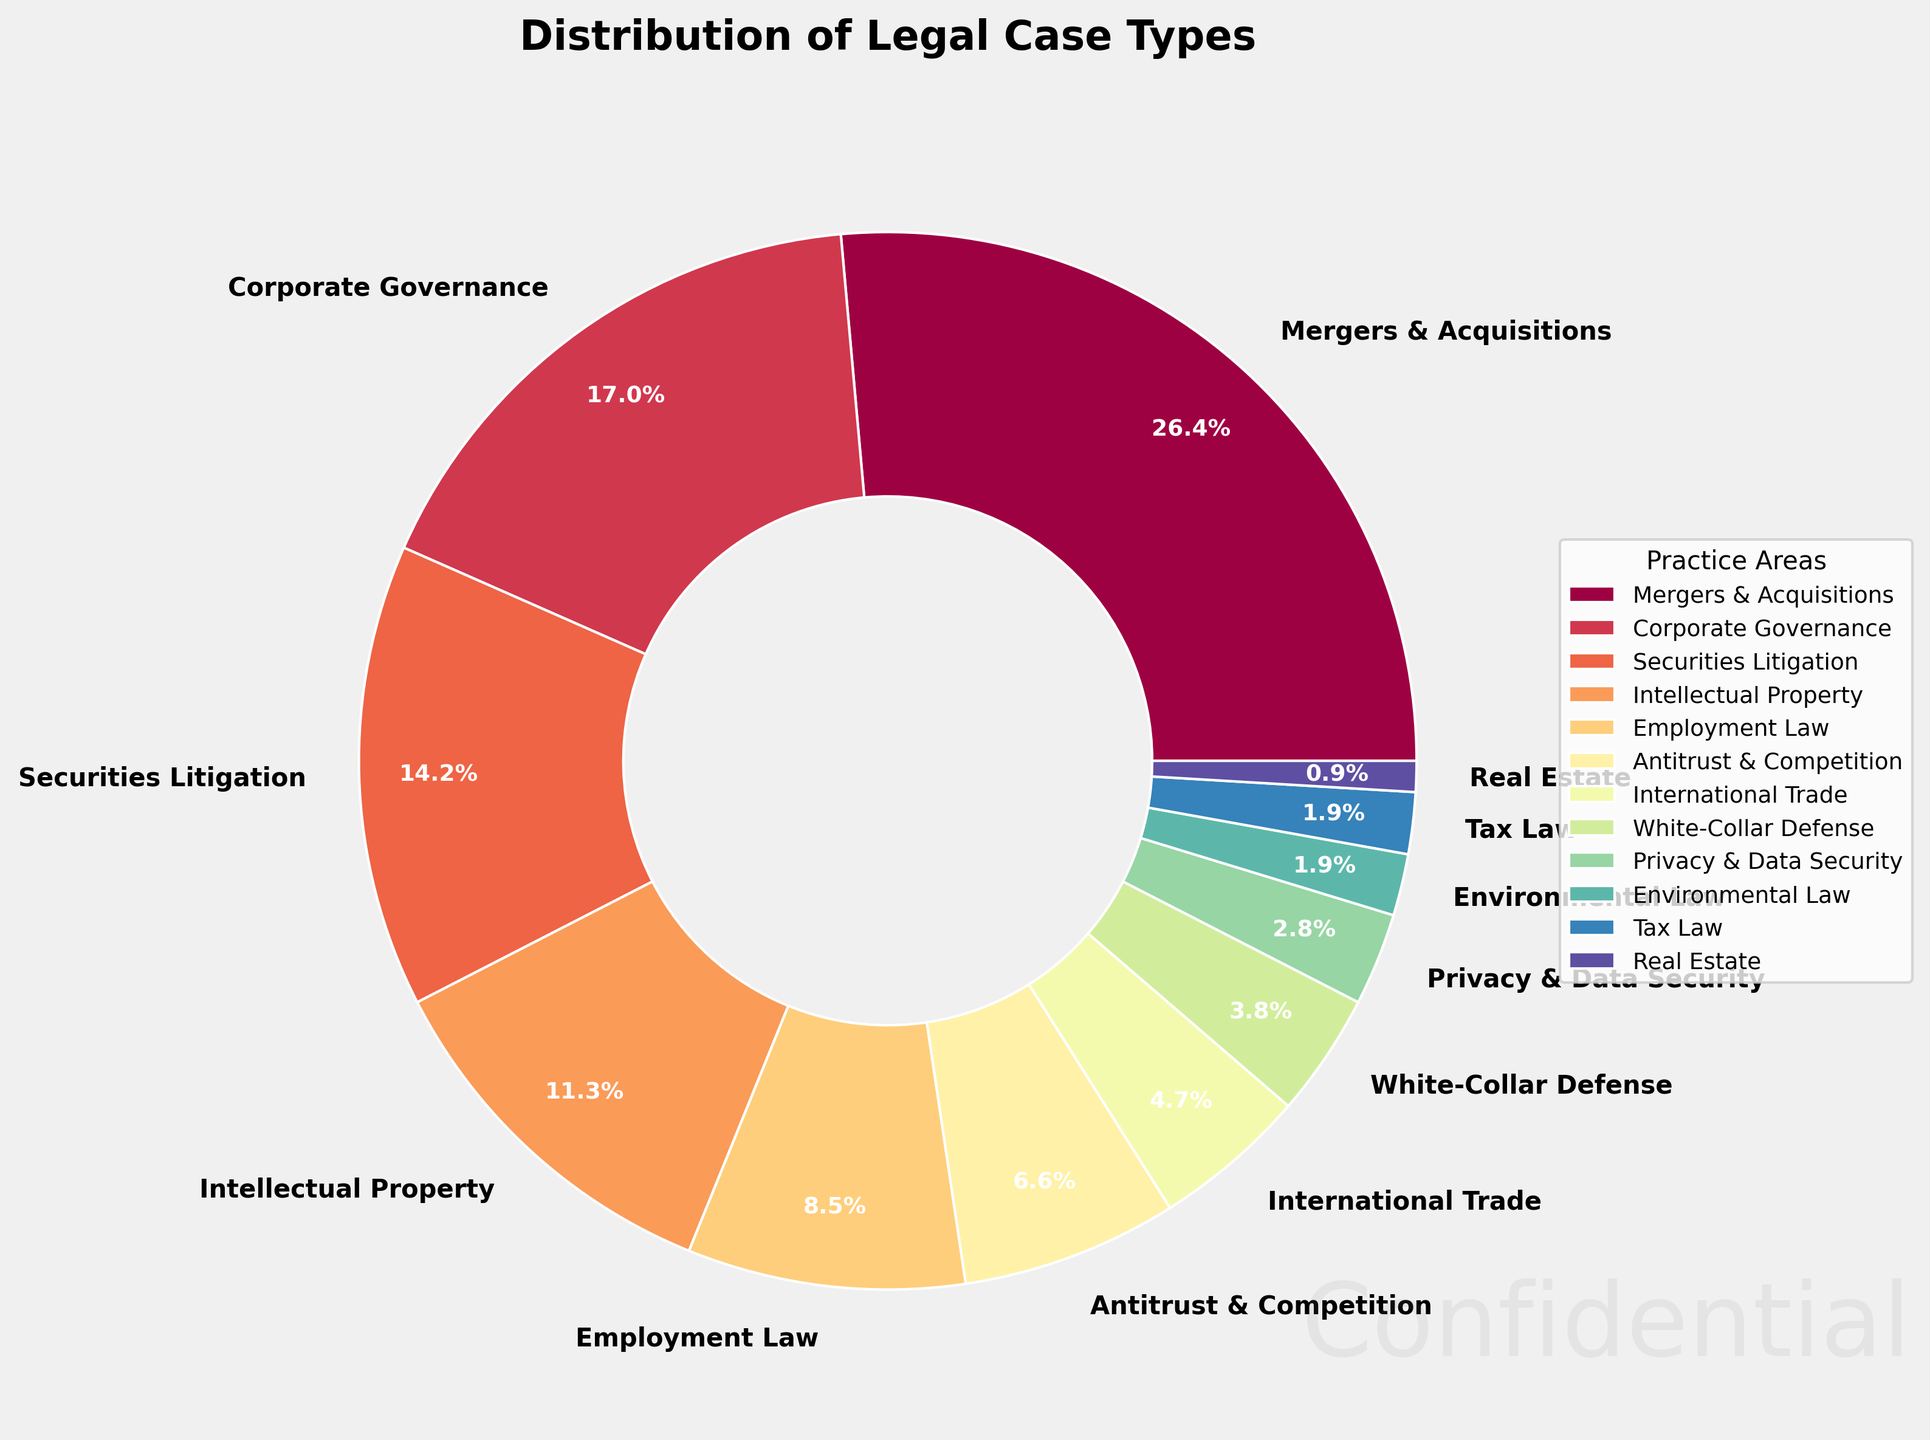What percentage of the firm's cases are related to Mergers & Acquisitions and Corporate Governance combined? Sum the percentages for Mergers & Acquisitions and Corporate Governance: 28% + 18% = 46%
Answer: 46% Which practice area deals with the smallest percentage of cases? Identify the practice area with the smallest percentage, which is Real Estate with 1%
Answer: Real Estate Is the percentage of cases handled by the Corporate Governance practice area greater than the percentage handled by the Employment Law practice area? Compare the percentages: 18% (Corporate Governance) > 9% (Employment Law)
Answer: Yes What is the difference in the percentage of cases between Intellectual Property and Employment Law? Calculate the difference: 12% (Intellectual Property) - 9% (Employment Law) = 3%
Answer: 3% What are the combined percentages of the three smallest practice areas? Sum the percentages of Privacy & Data Security, Environmental Law, and Real Estate: 3% + 2% + 1% = 6%
Answer: 6% Which practice areas together make up more than half of the firm's cases? Sum the largest percentages to exceed 50%: Mergers & Acquisitions (28%), Corporate Governance (18%), and Securities Litigation (15%) together make 61%.
Answer: Mergers & Acquisitions, Corporate Governance, Securities Litigation Are there more cases related to Securities Litigation or to Antitrust & Competition and Employment Law combined? Compare the percentages: Securities Litigation (15%) vs. Antitrust & Competition (7%) + Employment Law (9%) = 16%
Answer: No Which practice area has a percentage closest to the average percentage of all practice areas? Calculate the average: Sum all percentages (100%) / 12 practice areas = 8.33%; find the closest percentage, which is Employment Law with 9%
Answer: Employment Law What visual element indicates the segments' values in the pie chart? The segment sizes and the percentage labels inside each wedge indicate values.
Answer: Segment sizes and percentage labels Which practice areas are colored at the extremes of the spectrum used? Identify the colors at the extremes, likely the lightest and darkest colors in the color gradient applied. The lightest is Real Estate (1%) and the darkest is Mergers & Acquisitions (28%).
Answer: Real Estate and Mergers & Acquisitions 